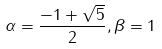Convert formula to latex. <formula><loc_0><loc_0><loc_500><loc_500>\alpha = \frac { - 1 + \sqrt { 5 } } { 2 } , \beta = 1</formula> 